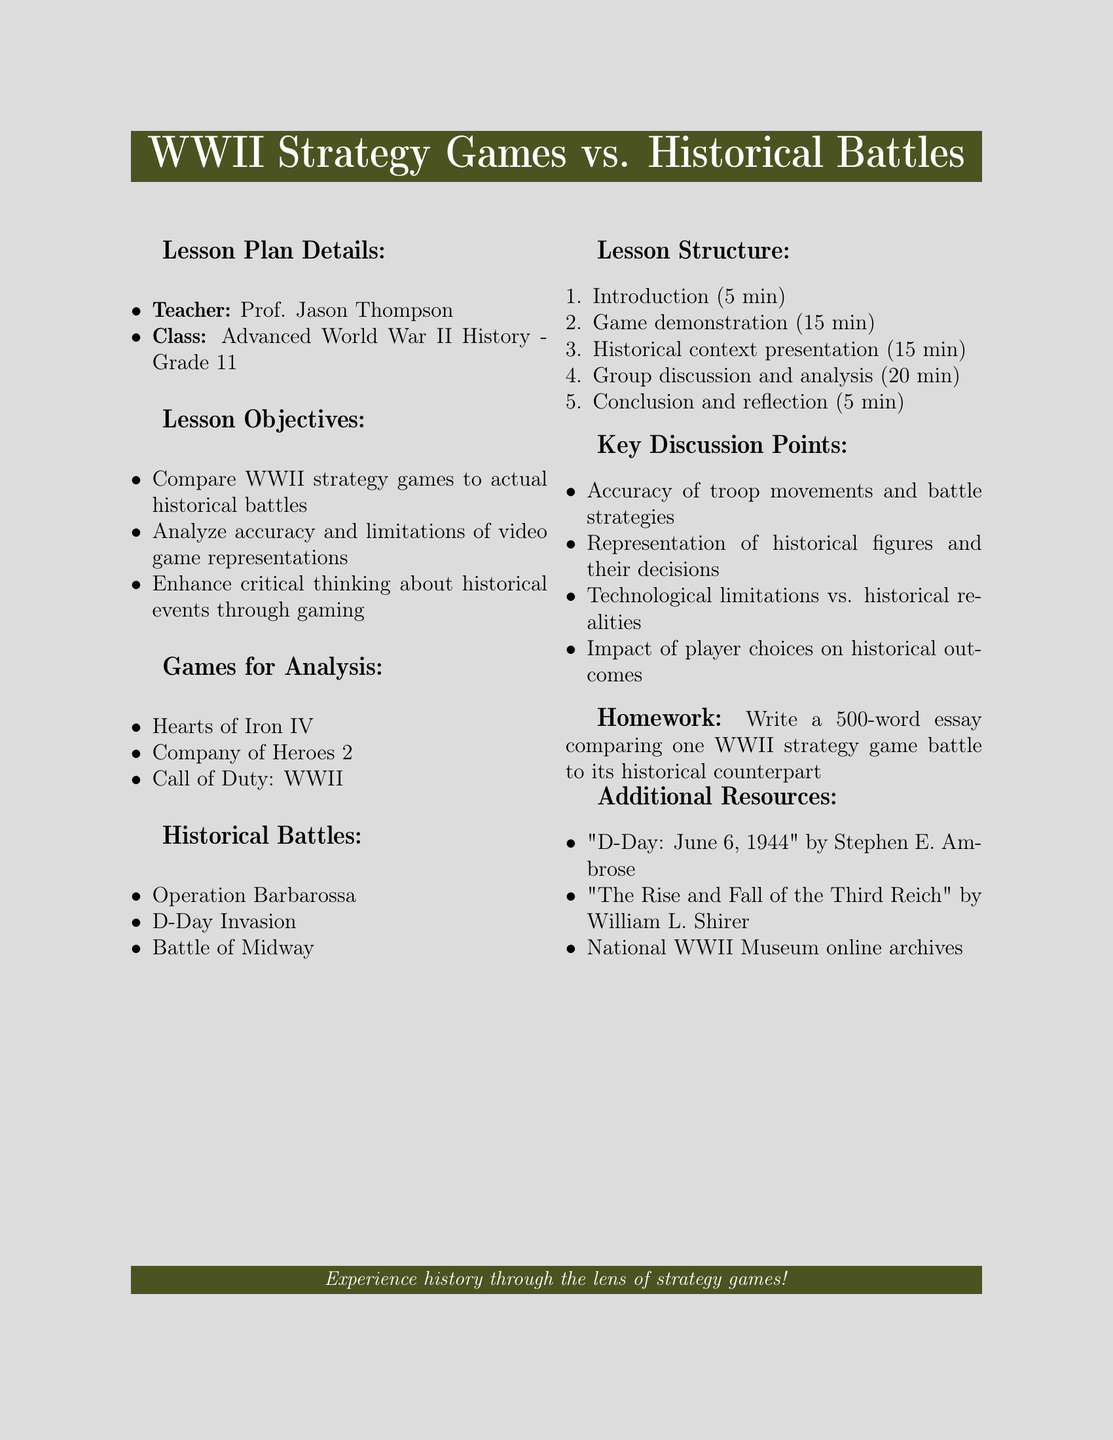What is the name of the teacher? The name of the teacher is mentioned in the lesson plan details section.
Answer: Prof. Jason Thompson What grade is the class for? The grade is specified in the class section of the lesson plan.
Answer: Grade 11 How long is the game demonstration? The duration of the game demonstration is explicitly stated in the lesson structure.
Answer: 15 min What is one of the key discussion points? Key discussion points are listed in the document, providing multiple options.
Answer: Accuracy of troop movements and battle strategies What is the homework assignment? The homework assignment is described in the last section of the document.
Answer: Write a 500-word essay comparing one WWII strategy game battle to its historical counterpart Which game is NOT listed for analysis? The games for analysis are explicitly listed, and one is to be identified as missing.
Answer: None; all listed games are: Hearts of Iron IV, Company of Heroes 2, Call of Duty: WWII What is one of the historical battles mentioned? Historical battles are listed, allowing for various choices.
Answer: D-Day Invasion How many minutes are allocated for the conclusion and reflection? The allocated time for this section is stated in the lesson structure.
Answer: 5 min 